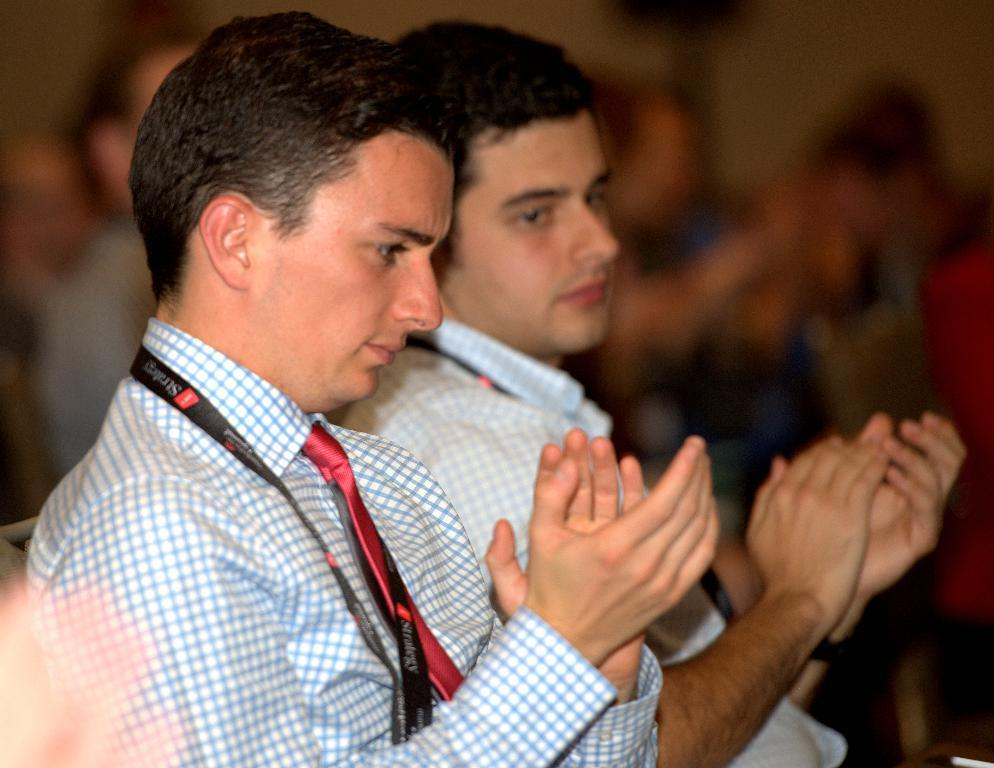How many people are in the image? There are two men in the image. What are the men doing in the image? The men are clapping. What are the men wearing around their necks? The men are wearing ties and tags. What is the condition of the background in the image? The background of the image is blurred. What are the men sitting on in the image? The men are sitting in chairs. How does the sand contribute to the balance of the men in the image? There is no sand present in the image, so it cannot contribute to the balance of the men. 